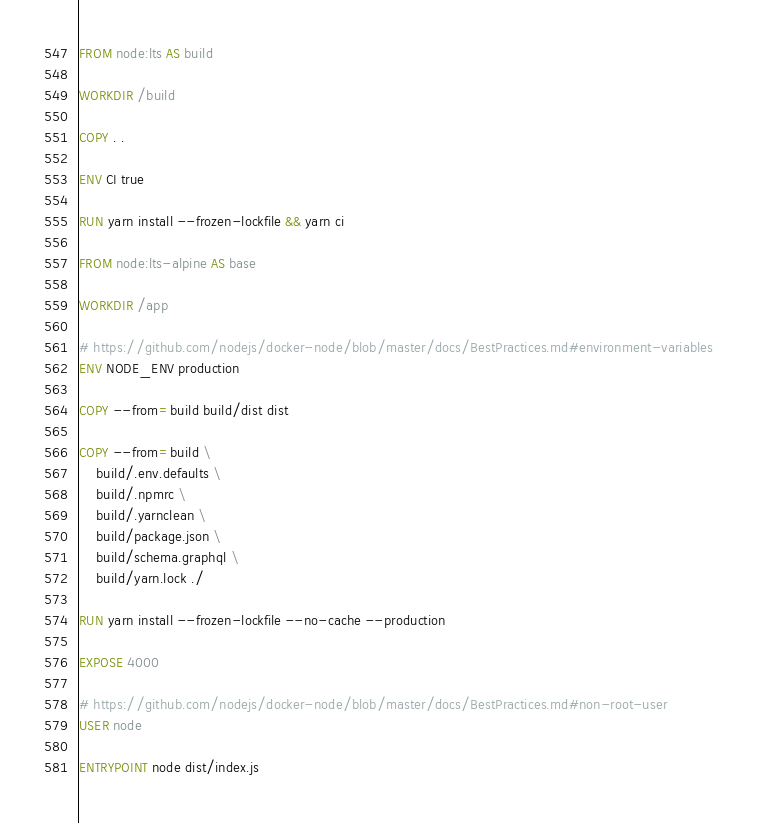<code> <loc_0><loc_0><loc_500><loc_500><_Dockerfile_>FROM node:lts AS build

WORKDIR /build

COPY . .

ENV CI true

RUN yarn install --frozen-lockfile && yarn ci

FROM node:lts-alpine AS base

WORKDIR /app

# https://github.com/nodejs/docker-node/blob/master/docs/BestPractices.md#environment-variables
ENV NODE_ENV production

COPY --from=build build/dist dist

COPY --from=build \
    build/.env.defaults \
    build/.npmrc \
    build/.yarnclean \
    build/package.json \
    build/schema.graphql \
    build/yarn.lock ./

RUN yarn install --frozen-lockfile --no-cache --production

EXPOSE 4000

# https://github.com/nodejs/docker-node/blob/master/docs/BestPractices.md#non-root-user
USER node

ENTRYPOINT node dist/index.js
</code> 